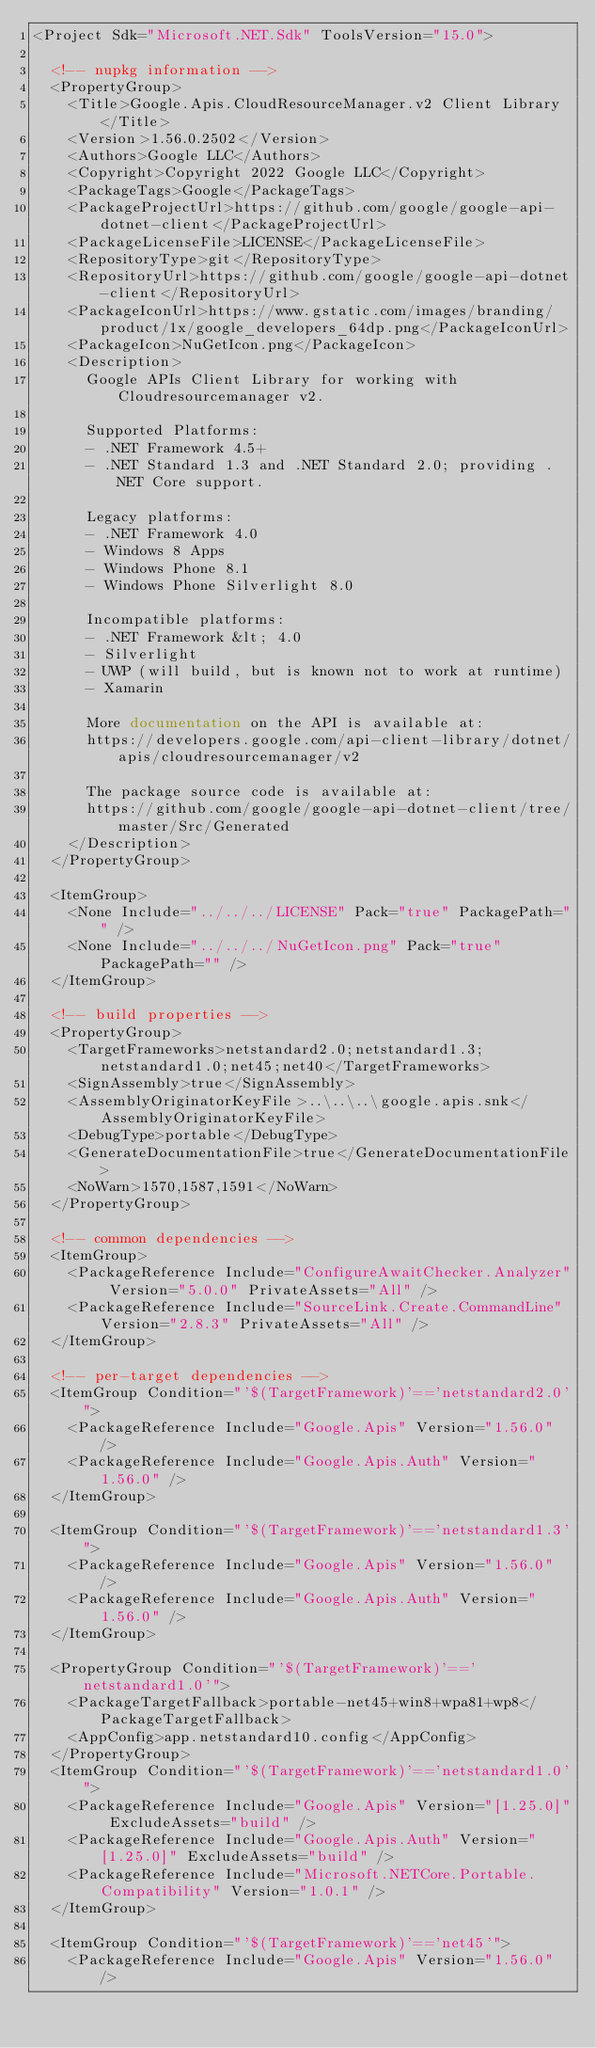<code> <loc_0><loc_0><loc_500><loc_500><_XML_><Project Sdk="Microsoft.NET.Sdk" ToolsVersion="15.0">

  <!-- nupkg information -->
  <PropertyGroup>
    <Title>Google.Apis.CloudResourceManager.v2 Client Library</Title>
    <Version>1.56.0.2502</Version>
    <Authors>Google LLC</Authors>
    <Copyright>Copyright 2022 Google LLC</Copyright>
    <PackageTags>Google</PackageTags>
    <PackageProjectUrl>https://github.com/google/google-api-dotnet-client</PackageProjectUrl>
    <PackageLicenseFile>LICENSE</PackageLicenseFile>
    <RepositoryType>git</RepositoryType>
    <RepositoryUrl>https://github.com/google/google-api-dotnet-client</RepositoryUrl>
    <PackageIconUrl>https://www.gstatic.com/images/branding/product/1x/google_developers_64dp.png</PackageIconUrl>
    <PackageIcon>NuGetIcon.png</PackageIcon>
    <Description>
      Google APIs Client Library for working with Cloudresourcemanager v2.

      Supported Platforms:
      - .NET Framework 4.5+
      - .NET Standard 1.3 and .NET Standard 2.0; providing .NET Core support.

      Legacy platforms:
      - .NET Framework 4.0
      - Windows 8 Apps
      - Windows Phone 8.1
      - Windows Phone Silverlight 8.0

      Incompatible platforms:
      - .NET Framework &lt; 4.0
      - Silverlight
      - UWP (will build, but is known not to work at runtime)
      - Xamarin

      More documentation on the API is available at:
      https://developers.google.com/api-client-library/dotnet/apis/cloudresourcemanager/v2

      The package source code is available at:
      https://github.com/google/google-api-dotnet-client/tree/master/Src/Generated
    </Description>
  </PropertyGroup>

  <ItemGroup>
    <None Include="../../../LICENSE" Pack="true" PackagePath="" />
    <None Include="../../../NuGetIcon.png" Pack="true" PackagePath="" />
  </ItemGroup>

  <!-- build properties -->
  <PropertyGroup>
    <TargetFrameworks>netstandard2.0;netstandard1.3;netstandard1.0;net45;net40</TargetFrameworks>
    <SignAssembly>true</SignAssembly>
    <AssemblyOriginatorKeyFile>..\..\..\google.apis.snk</AssemblyOriginatorKeyFile>
    <DebugType>portable</DebugType>
    <GenerateDocumentationFile>true</GenerateDocumentationFile>
    <NoWarn>1570,1587,1591</NoWarn>
  </PropertyGroup>

  <!-- common dependencies -->
  <ItemGroup>
    <PackageReference Include="ConfigureAwaitChecker.Analyzer" Version="5.0.0" PrivateAssets="All" />
    <PackageReference Include="SourceLink.Create.CommandLine" Version="2.8.3" PrivateAssets="All" />
  </ItemGroup>

  <!-- per-target dependencies -->
  <ItemGroup Condition="'$(TargetFramework)'=='netstandard2.0'">
    <PackageReference Include="Google.Apis" Version="1.56.0" />
    <PackageReference Include="Google.Apis.Auth" Version="1.56.0" />
  </ItemGroup>

  <ItemGroup Condition="'$(TargetFramework)'=='netstandard1.3'">
    <PackageReference Include="Google.Apis" Version="1.56.0" />
    <PackageReference Include="Google.Apis.Auth" Version="1.56.0" />
  </ItemGroup>

  <PropertyGroup Condition="'$(TargetFramework)'=='netstandard1.0'">
    <PackageTargetFallback>portable-net45+win8+wpa81+wp8</PackageTargetFallback>
    <AppConfig>app.netstandard10.config</AppConfig>
  </PropertyGroup>
  <ItemGroup Condition="'$(TargetFramework)'=='netstandard1.0'">
    <PackageReference Include="Google.Apis" Version="[1.25.0]" ExcludeAssets="build" />
    <PackageReference Include="Google.Apis.Auth" Version="[1.25.0]" ExcludeAssets="build" />
    <PackageReference Include="Microsoft.NETCore.Portable.Compatibility" Version="1.0.1" />
  </ItemGroup>

  <ItemGroup Condition="'$(TargetFramework)'=='net45'">
    <PackageReference Include="Google.Apis" Version="1.56.0" /></code> 